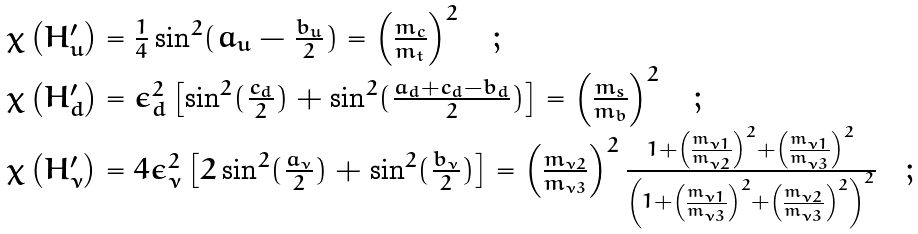Convert formula to latex. <formula><loc_0><loc_0><loc_500><loc_500>\begin{array} { l } \chi \left ( H _ { u } ^ { \prime } \right ) = \frac { 1 } { 4 } \sin ^ { 2 } ( a _ { u } - \frac { b _ { u } } { 2 } ) = \left ( \frac { m _ { c } } { m _ { t } } \right ) ^ { 2 } \quad ; \\ \chi \left ( H _ { d } ^ { \prime } \right ) = \epsilon _ { d } ^ { 2 } \left [ \sin ^ { 2 } ( \frac { c _ { d } } { 2 } ) + \sin ^ { 2 } ( \frac { a _ { d } + c _ { d } - b _ { d } } { 2 } ) \right ] = \left ( \frac { m _ { s } } { m _ { b } } \right ) ^ { 2 } \quad ; \\ \chi \left ( H _ { \nu } ^ { \prime } \right ) = 4 \epsilon _ { \nu } ^ { 2 } \left [ 2 \sin ^ { 2 } ( \frac { a _ { \nu } } { 2 } ) + \sin ^ { 2 } ( \frac { b _ { \nu } } { 2 } ) \right ] = \left ( \frac { m _ { \nu 2 } } { m _ { \nu 3 } } \right ) ^ { 2 } \frac { 1 + \left ( \frac { m _ { \nu 1 } } { m _ { \nu 2 } } \right ) ^ { 2 } + \left ( \frac { m _ { \nu 1 } } { m _ { \nu 3 } } \right ) ^ { 2 } } { \left ( 1 + \left ( \frac { m _ { \nu 1 } } { m _ { \nu 3 } } \right ) ^ { 2 } + \left ( \frac { m _ { \nu 2 } } { m _ { \nu 3 } } \right ) ^ { 2 } \right ) ^ { 2 } } \quad ; \end{array}</formula> 